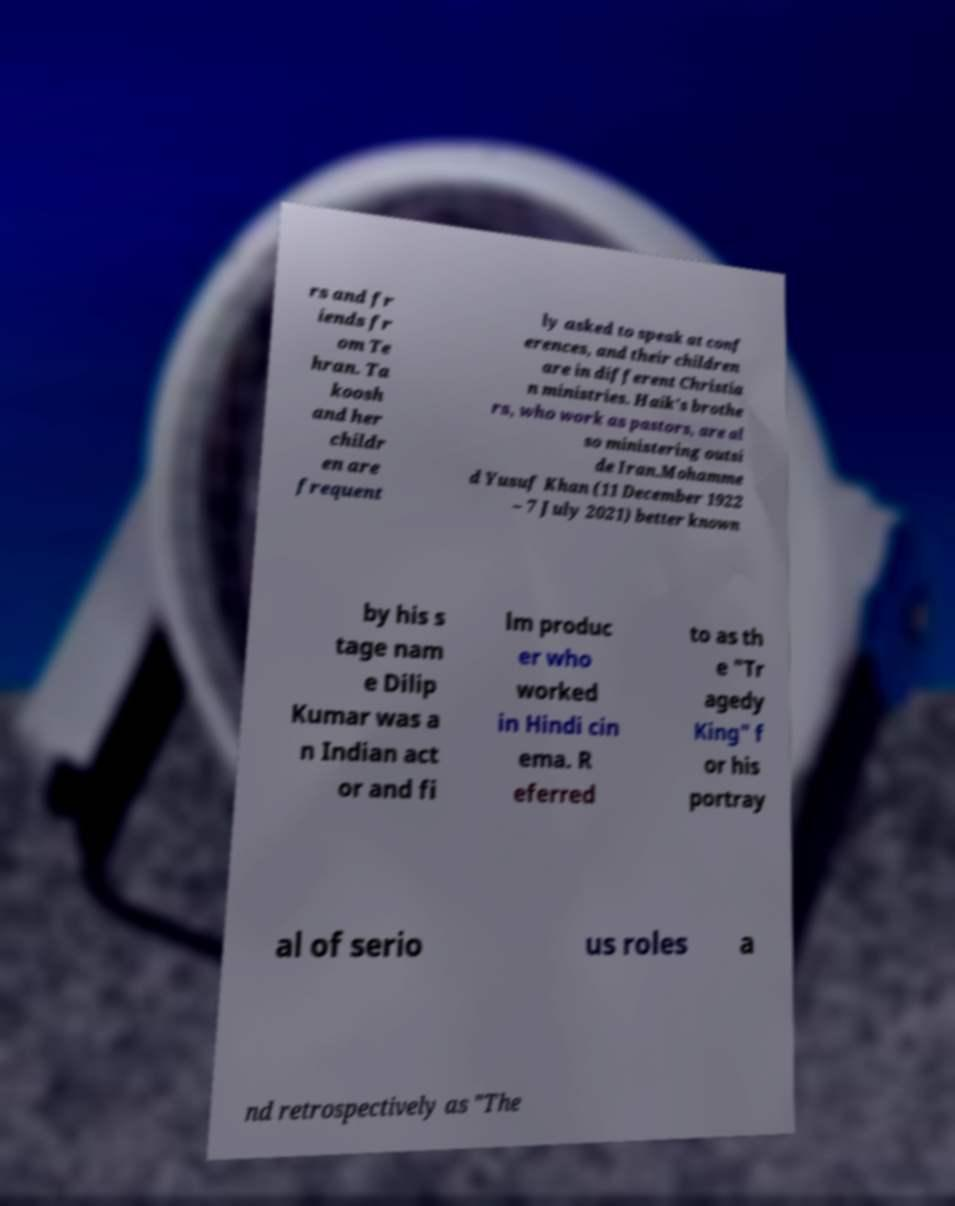Please read and relay the text visible in this image. What does it say? rs and fr iends fr om Te hran. Ta koosh and her childr en are frequent ly asked to speak at conf erences, and their children are in different Christia n ministries. Haik's brothe rs, who work as pastors, are al so ministering outsi de Iran.Mohamme d Yusuf Khan (11 December 1922 – 7 July 2021) better known by his s tage nam e Dilip Kumar was a n Indian act or and fi lm produc er who worked in Hindi cin ema. R eferred to as th e "Tr agedy King" f or his portray al of serio us roles a nd retrospectively as "The 